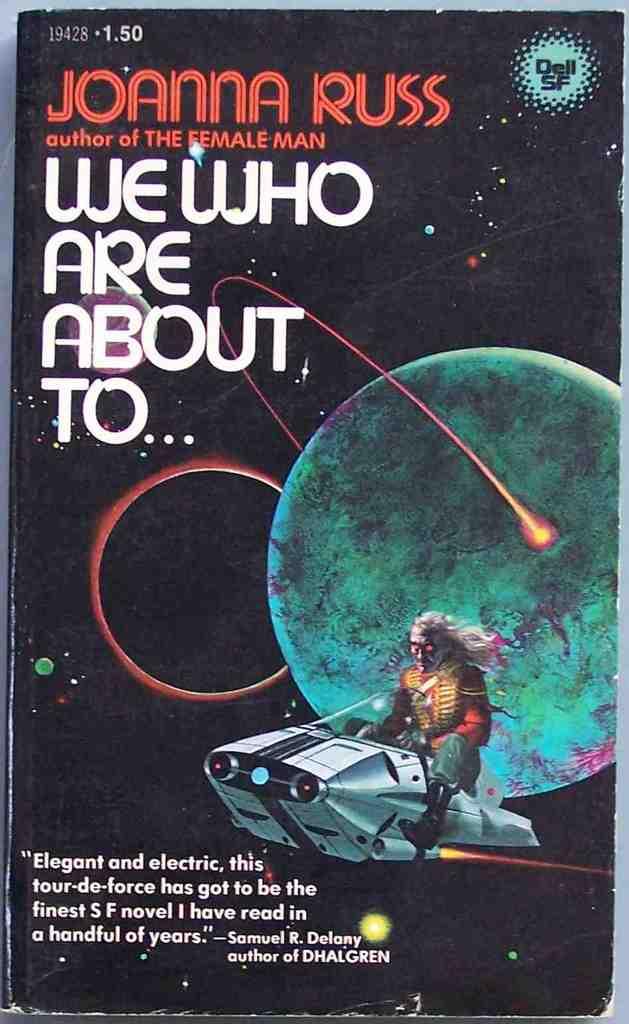Who is the author of this book?
Make the answer very short. Joanna russ. Which other book has joanna russ written?
Offer a very short reply. The female man. 